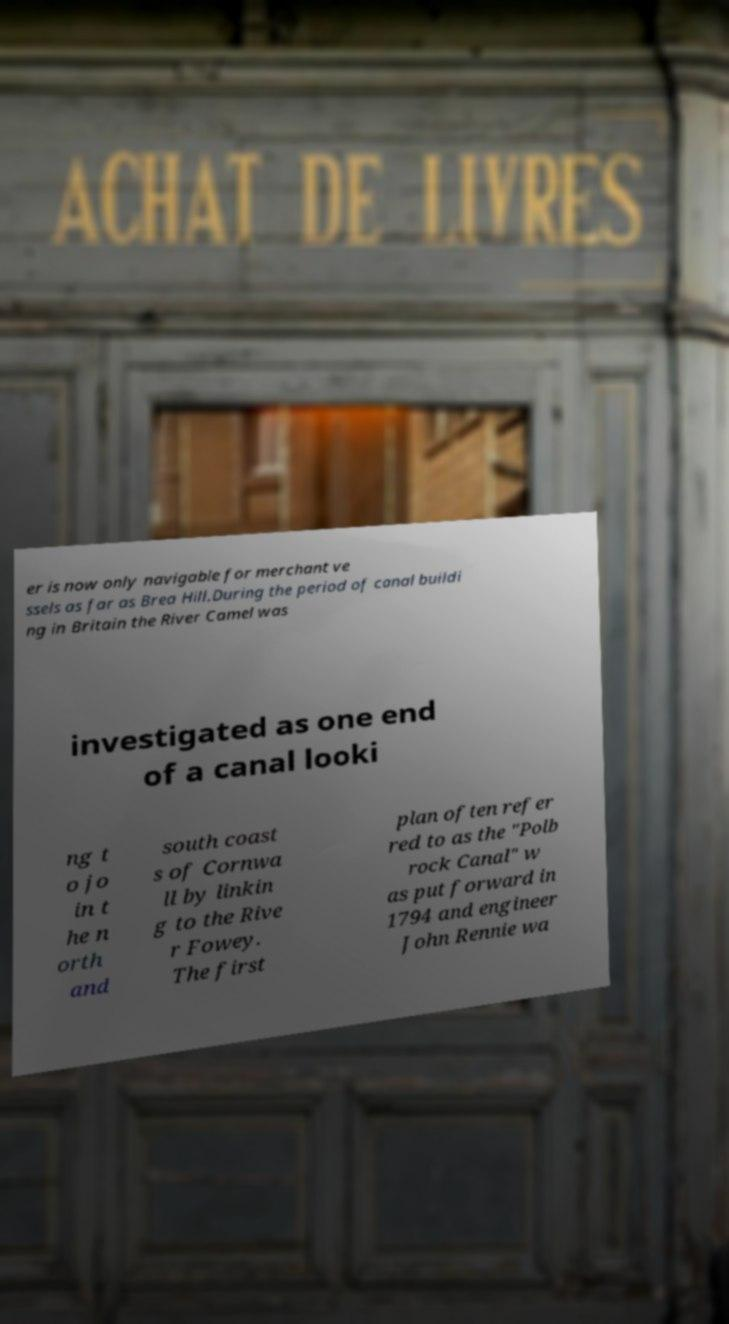Could you assist in decoding the text presented in this image and type it out clearly? er is now only navigable for merchant ve ssels as far as Brea Hill.During the period of canal buildi ng in Britain the River Camel was investigated as one end of a canal looki ng t o jo in t he n orth and south coast s of Cornwa ll by linkin g to the Rive r Fowey. The first plan often refer red to as the "Polb rock Canal" w as put forward in 1794 and engineer John Rennie wa 